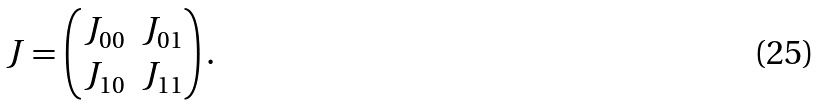Convert formula to latex. <formula><loc_0><loc_0><loc_500><loc_500>J = \begin{pmatrix} J _ { 0 0 } & J _ { 0 1 } \\ J _ { 1 0 } & J _ { 1 1 } \end{pmatrix} .</formula> 